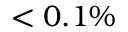Convert formula to latex. <formula><loc_0><loc_0><loc_500><loc_500>< 0 . 1 \%</formula> 